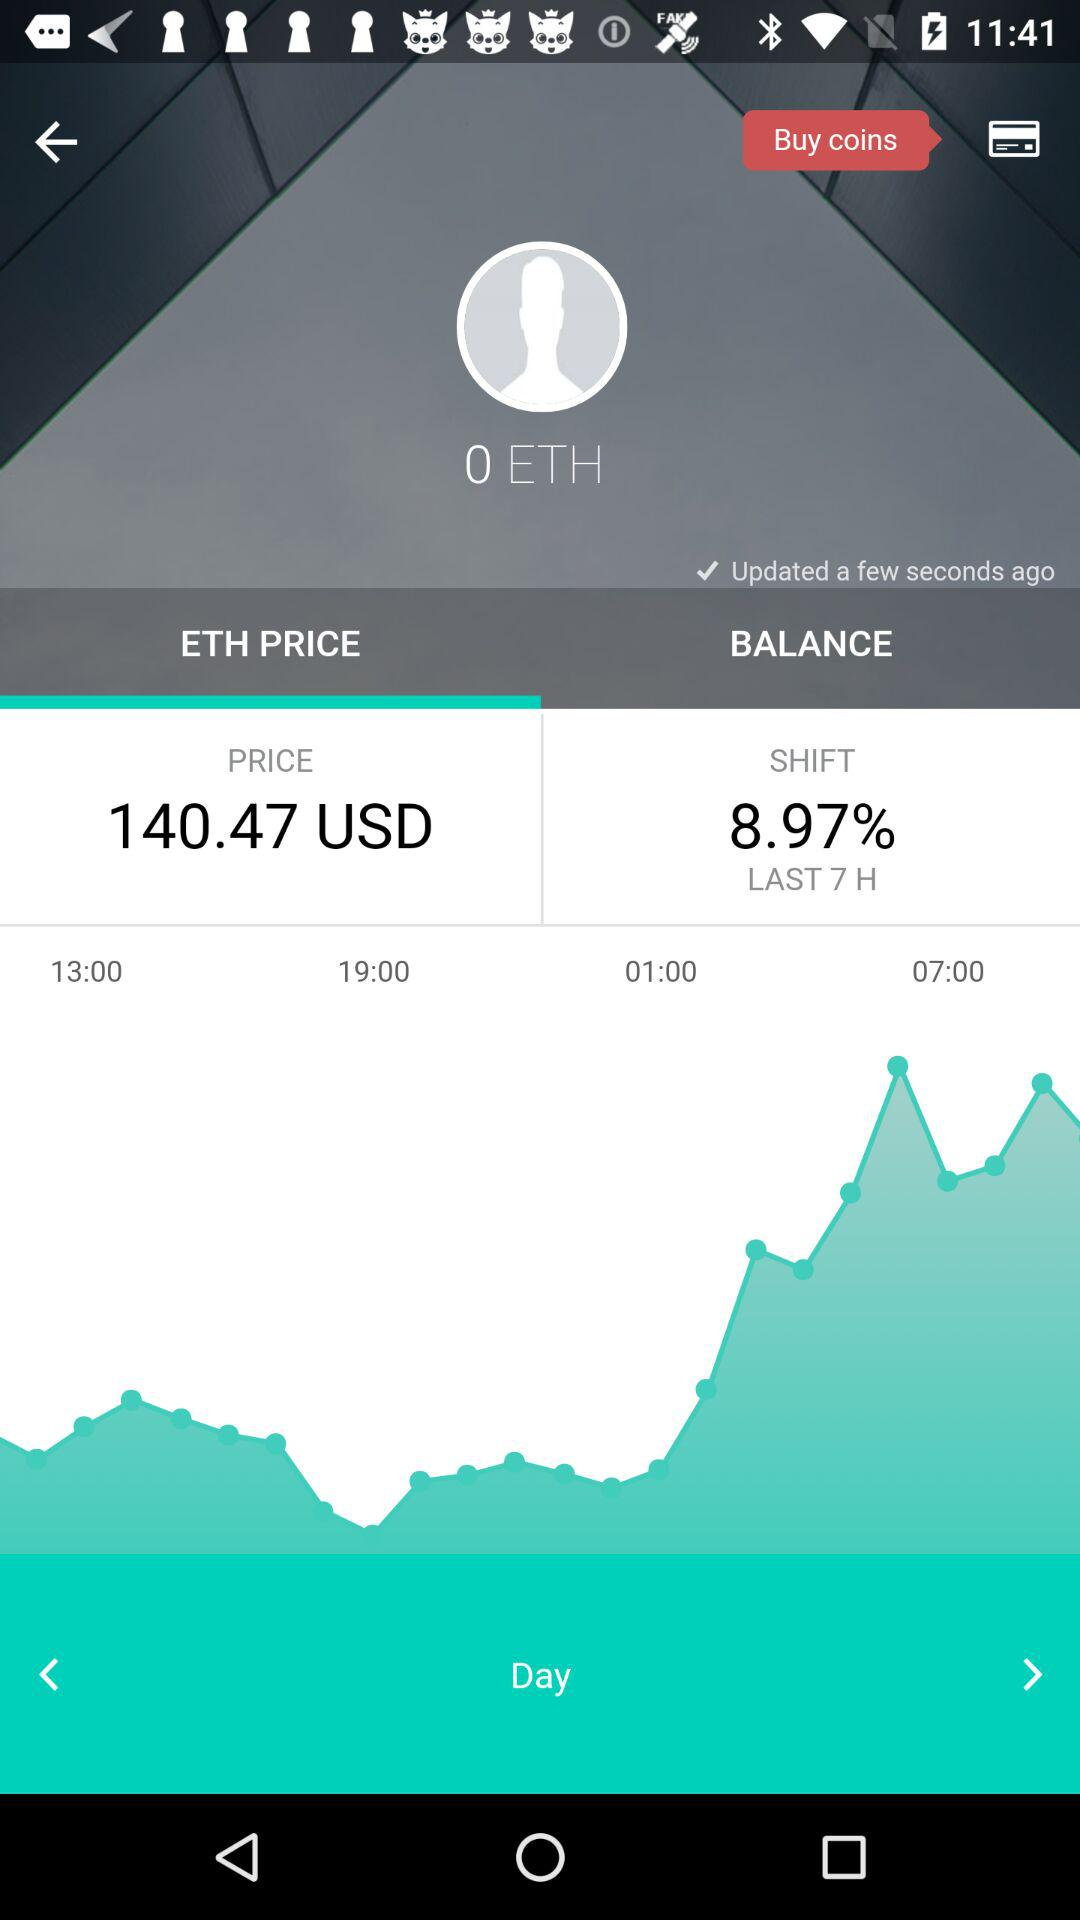When was it last updated? It was last updated a few seconds ago. 